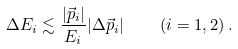Convert formula to latex. <formula><loc_0><loc_0><loc_500><loc_500>\Delta E _ { i } \lesssim \frac { | \vec { p } _ { i } | } { E _ { i } } | \Delta \vec { p } _ { i } | \quad ( i = 1 , 2 ) \, .</formula> 